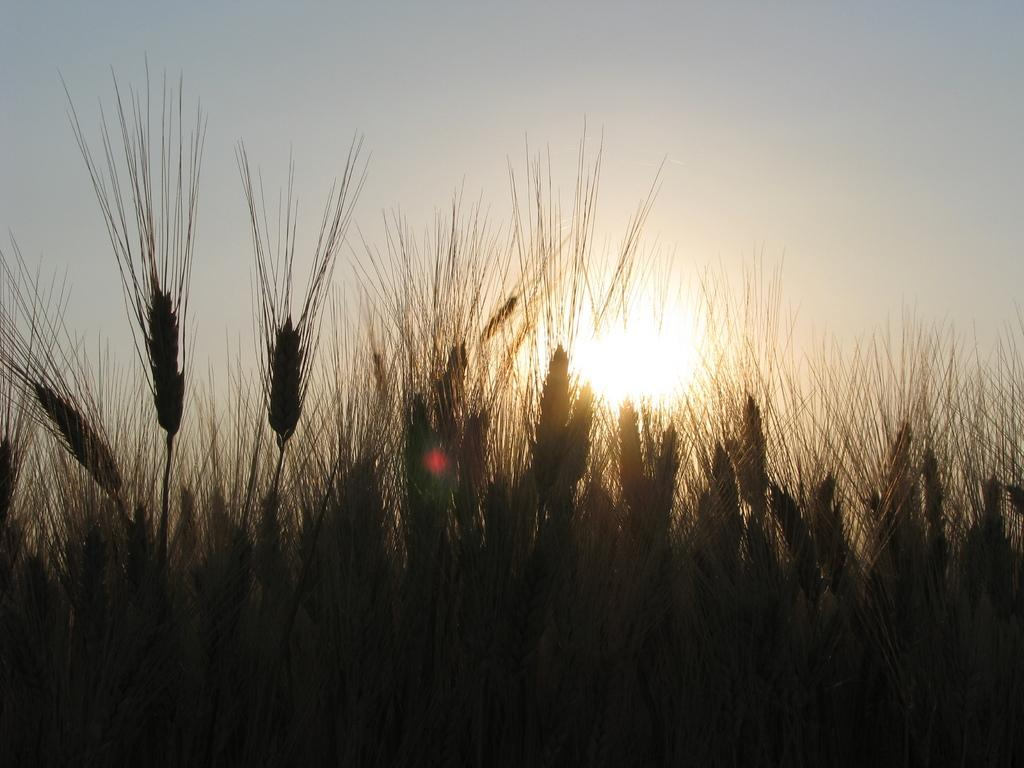What is the main subject of the image? The main subject of the image is a crop. What can be seen in the sky at the top of the image? The sun is visible in the sky at the top of the image. How many bricks are stacked on the crop in the image? There are no bricks present in the image; it features a crop and the sun in the sky. What time does the clock show in the image? There is no clock present in the image. 